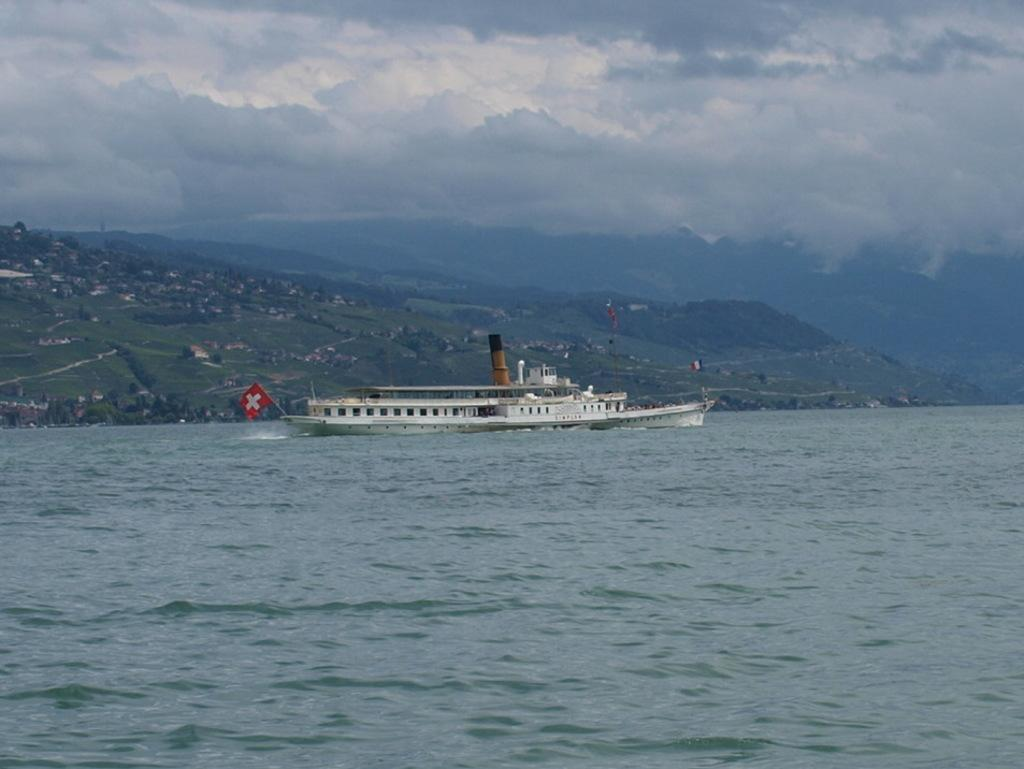What is the main subject of the image? There is a ship in the image. Can you describe the ship's position in relation to the water? The ship is above the water in the image. What can be seen in the background of the image? There are hills, trees, houses, and a cloudy sky in the background of the image. What type of operation is being performed on the ship in the image? There is no operation being performed on the ship in the image; it is simply floating above the water. How many tickets are visible for passengers to board the ship in the image? There are no tickets visible in the image, as it does not show any passengers or boarding process. 